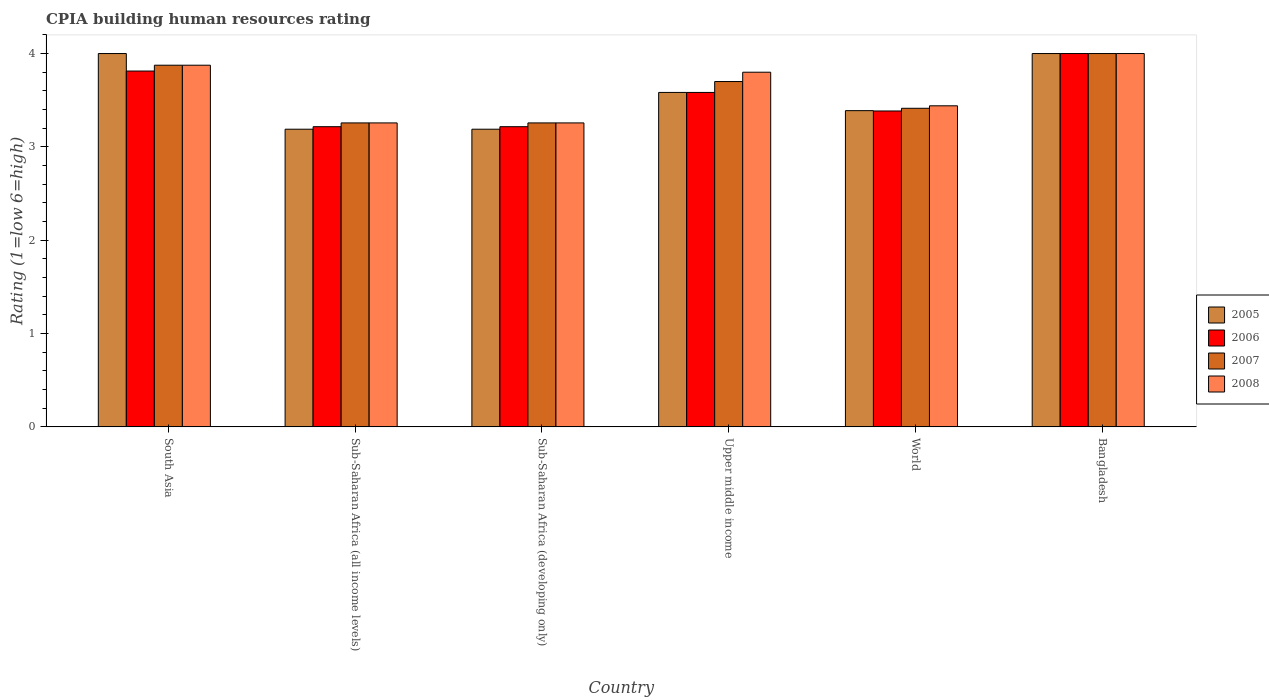How many different coloured bars are there?
Your response must be concise. 4. How many groups of bars are there?
Your answer should be compact. 6. Are the number of bars on each tick of the X-axis equal?
Make the answer very short. Yes. How many bars are there on the 1st tick from the right?
Give a very brief answer. 4. What is the label of the 3rd group of bars from the left?
Offer a very short reply. Sub-Saharan Africa (developing only). In how many cases, is the number of bars for a given country not equal to the number of legend labels?
Provide a succinct answer. 0. What is the CPIA rating in 2005 in Bangladesh?
Your response must be concise. 4. Across all countries, what is the minimum CPIA rating in 2007?
Give a very brief answer. 3.26. In which country was the CPIA rating in 2008 maximum?
Provide a short and direct response. Bangladesh. In which country was the CPIA rating in 2007 minimum?
Your response must be concise. Sub-Saharan Africa (all income levels). What is the total CPIA rating in 2005 in the graph?
Ensure brevity in your answer.  21.35. What is the difference between the CPIA rating in 2007 in Sub-Saharan Africa (developing only) and that in World?
Make the answer very short. -0.16. What is the difference between the CPIA rating in 2007 in Sub-Saharan Africa (all income levels) and the CPIA rating in 2005 in Sub-Saharan Africa (developing only)?
Your answer should be very brief. 0.07. What is the average CPIA rating in 2006 per country?
Ensure brevity in your answer.  3.54. What is the difference between the CPIA rating of/in 2008 and CPIA rating of/in 2005 in Upper middle income?
Offer a terse response. 0.22. What is the ratio of the CPIA rating in 2007 in Bangladesh to that in Sub-Saharan Africa (developing only)?
Offer a terse response. 1.23. What is the difference between the highest and the second highest CPIA rating in 2005?
Provide a short and direct response. -0.42. What is the difference between the highest and the lowest CPIA rating in 2007?
Your answer should be compact. 0.74. Is the sum of the CPIA rating in 2006 in South Asia and World greater than the maximum CPIA rating in 2007 across all countries?
Give a very brief answer. Yes. What does the 3rd bar from the left in Bangladesh represents?
Your response must be concise. 2007. What does the 1st bar from the right in Sub-Saharan Africa (all income levels) represents?
Your response must be concise. 2008. Is it the case that in every country, the sum of the CPIA rating in 2006 and CPIA rating in 2005 is greater than the CPIA rating in 2007?
Provide a short and direct response. Yes. What is the difference between two consecutive major ticks on the Y-axis?
Make the answer very short. 1. Does the graph contain any zero values?
Offer a terse response. No. Does the graph contain grids?
Provide a succinct answer. No. How many legend labels are there?
Your response must be concise. 4. How are the legend labels stacked?
Provide a succinct answer. Vertical. What is the title of the graph?
Your answer should be very brief. CPIA building human resources rating. Does "1999" appear as one of the legend labels in the graph?
Your answer should be very brief. No. What is the label or title of the X-axis?
Your response must be concise. Country. What is the label or title of the Y-axis?
Offer a very short reply. Rating (1=low 6=high). What is the Rating (1=low 6=high) in 2006 in South Asia?
Ensure brevity in your answer.  3.81. What is the Rating (1=low 6=high) of 2007 in South Asia?
Make the answer very short. 3.88. What is the Rating (1=low 6=high) of 2008 in South Asia?
Offer a very short reply. 3.88. What is the Rating (1=low 6=high) of 2005 in Sub-Saharan Africa (all income levels)?
Provide a succinct answer. 3.19. What is the Rating (1=low 6=high) of 2006 in Sub-Saharan Africa (all income levels)?
Provide a succinct answer. 3.22. What is the Rating (1=low 6=high) of 2007 in Sub-Saharan Africa (all income levels)?
Give a very brief answer. 3.26. What is the Rating (1=low 6=high) of 2008 in Sub-Saharan Africa (all income levels)?
Your answer should be very brief. 3.26. What is the Rating (1=low 6=high) in 2005 in Sub-Saharan Africa (developing only)?
Offer a very short reply. 3.19. What is the Rating (1=low 6=high) in 2006 in Sub-Saharan Africa (developing only)?
Make the answer very short. 3.22. What is the Rating (1=low 6=high) of 2007 in Sub-Saharan Africa (developing only)?
Provide a short and direct response. 3.26. What is the Rating (1=low 6=high) of 2008 in Sub-Saharan Africa (developing only)?
Make the answer very short. 3.26. What is the Rating (1=low 6=high) of 2005 in Upper middle income?
Your answer should be compact. 3.58. What is the Rating (1=low 6=high) in 2006 in Upper middle income?
Your answer should be very brief. 3.58. What is the Rating (1=low 6=high) of 2007 in Upper middle income?
Provide a short and direct response. 3.7. What is the Rating (1=low 6=high) of 2005 in World?
Make the answer very short. 3.39. What is the Rating (1=low 6=high) of 2006 in World?
Offer a very short reply. 3.38. What is the Rating (1=low 6=high) of 2007 in World?
Offer a terse response. 3.41. What is the Rating (1=low 6=high) of 2008 in World?
Your answer should be compact. 3.44. What is the Rating (1=low 6=high) in 2006 in Bangladesh?
Offer a very short reply. 4. What is the Rating (1=low 6=high) of 2007 in Bangladesh?
Keep it short and to the point. 4. What is the Rating (1=low 6=high) of 2008 in Bangladesh?
Your answer should be compact. 4. Across all countries, what is the maximum Rating (1=low 6=high) in 2006?
Offer a terse response. 4. Across all countries, what is the maximum Rating (1=low 6=high) of 2008?
Your answer should be very brief. 4. Across all countries, what is the minimum Rating (1=low 6=high) of 2005?
Give a very brief answer. 3.19. Across all countries, what is the minimum Rating (1=low 6=high) of 2006?
Provide a short and direct response. 3.22. Across all countries, what is the minimum Rating (1=low 6=high) in 2007?
Provide a short and direct response. 3.26. Across all countries, what is the minimum Rating (1=low 6=high) of 2008?
Keep it short and to the point. 3.26. What is the total Rating (1=low 6=high) in 2005 in the graph?
Provide a succinct answer. 21.35. What is the total Rating (1=low 6=high) of 2006 in the graph?
Your answer should be compact. 21.21. What is the total Rating (1=low 6=high) of 2007 in the graph?
Offer a terse response. 21.5. What is the total Rating (1=low 6=high) of 2008 in the graph?
Your answer should be very brief. 21.63. What is the difference between the Rating (1=low 6=high) of 2005 in South Asia and that in Sub-Saharan Africa (all income levels)?
Make the answer very short. 0.81. What is the difference between the Rating (1=low 6=high) of 2006 in South Asia and that in Sub-Saharan Africa (all income levels)?
Give a very brief answer. 0.6. What is the difference between the Rating (1=low 6=high) in 2007 in South Asia and that in Sub-Saharan Africa (all income levels)?
Provide a succinct answer. 0.62. What is the difference between the Rating (1=low 6=high) in 2008 in South Asia and that in Sub-Saharan Africa (all income levels)?
Make the answer very short. 0.62. What is the difference between the Rating (1=low 6=high) of 2005 in South Asia and that in Sub-Saharan Africa (developing only)?
Offer a very short reply. 0.81. What is the difference between the Rating (1=low 6=high) in 2006 in South Asia and that in Sub-Saharan Africa (developing only)?
Your answer should be compact. 0.6. What is the difference between the Rating (1=low 6=high) of 2007 in South Asia and that in Sub-Saharan Africa (developing only)?
Provide a succinct answer. 0.62. What is the difference between the Rating (1=low 6=high) in 2008 in South Asia and that in Sub-Saharan Africa (developing only)?
Your answer should be compact. 0.62. What is the difference between the Rating (1=low 6=high) in 2005 in South Asia and that in Upper middle income?
Offer a terse response. 0.42. What is the difference between the Rating (1=low 6=high) in 2006 in South Asia and that in Upper middle income?
Make the answer very short. 0.23. What is the difference between the Rating (1=low 6=high) in 2007 in South Asia and that in Upper middle income?
Make the answer very short. 0.17. What is the difference between the Rating (1=low 6=high) of 2008 in South Asia and that in Upper middle income?
Keep it short and to the point. 0.07. What is the difference between the Rating (1=low 6=high) in 2005 in South Asia and that in World?
Your answer should be compact. 0.61. What is the difference between the Rating (1=low 6=high) in 2006 in South Asia and that in World?
Ensure brevity in your answer.  0.43. What is the difference between the Rating (1=low 6=high) of 2007 in South Asia and that in World?
Offer a terse response. 0.46. What is the difference between the Rating (1=low 6=high) in 2008 in South Asia and that in World?
Your response must be concise. 0.43. What is the difference between the Rating (1=low 6=high) of 2006 in South Asia and that in Bangladesh?
Your answer should be compact. -0.19. What is the difference between the Rating (1=low 6=high) in 2007 in South Asia and that in Bangladesh?
Give a very brief answer. -0.12. What is the difference between the Rating (1=low 6=high) in 2008 in South Asia and that in Bangladesh?
Offer a very short reply. -0.12. What is the difference between the Rating (1=low 6=high) of 2005 in Sub-Saharan Africa (all income levels) and that in Upper middle income?
Your answer should be very brief. -0.39. What is the difference between the Rating (1=low 6=high) in 2006 in Sub-Saharan Africa (all income levels) and that in Upper middle income?
Your answer should be very brief. -0.37. What is the difference between the Rating (1=low 6=high) in 2007 in Sub-Saharan Africa (all income levels) and that in Upper middle income?
Your response must be concise. -0.44. What is the difference between the Rating (1=low 6=high) in 2008 in Sub-Saharan Africa (all income levels) and that in Upper middle income?
Give a very brief answer. -0.54. What is the difference between the Rating (1=low 6=high) of 2005 in Sub-Saharan Africa (all income levels) and that in World?
Offer a terse response. -0.2. What is the difference between the Rating (1=low 6=high) in 2006 in Sub-Saharan Africa (all income levels) and that in World?
Keep it short and to the point. -0.17. What is the difference between the Rating (1=low 6=high) in 2007 in Sub-Saharan Africa (all income levels) and that in World?
Make the answer very short. -0.16. What is the difference between the Rating (1=low 6=high) in 2008 in Sub-Saharan Africa (all income levels) and that in World?
Give a very brief answer. -0.18. What is the difference between the Rating (1=low 6=high) of 2005 in Sub-Saharan Africa (all income levels) and that in Bangladesh?
Offer a terse response. -0.81. What is the difference between the Rating (1=low 6=high) in 2006 in Sub-Saharan Africa (all income levels) and that in Bangladesh?
Your answer should be compact. -0.78. What is the difference between the Rating (1=low 6=high) of 2007 in Sub-Saharan Africa (all income levels) and that in Bangladesh?
Keep it short and to the point. -0.74. What is the difference between the Rating (1=low 6=high) in 2008 in Sub-Saharan Africa (all income levels) and that in Bangladesh?
Give a very brief answer. -0.74. What is the difference between the Rating (1=low 6=high) of 2005 in Sub-Saharan Africa (developing only) and that in Upper middle income?
Keep it short and to the point. -0.39. What is the difference between the Rating (1=low 6=high) in 2006 in Sub-Saharan Africa (developing only) and that in Upper middle income?
Give a very brief answer. -0.37. What is the difference between the Rating (1=low 6=high) of 2007 in Sub-Saharan Africa (developing only) and that in Upper middle income?
Your answer should be compact. -0.44. What is the difference between the Rating (1=low 6=high) in 2008 in Sub-Saharan Africa (developing only) and that in Upper middle income?
Give a very brief answer. -0.54. What is the difference between the Rating (1=low 6=high) in 2005 in Sub-Saharan Africa (developing only) and that in World?
Your response must be concise. -0.2. What is the difference between the Rating (1=low 6=high) in 2006 in Sub-Saharan Africa (developing only) and that in World?
Offer a very short reply. -0.17. What is the difference between the Rating (1=low 6=high) in 2007 in Sub-Saharan Africa (developing only) and that in World?
Provide a succinct answer. -0.16. What is the difference between the Rating (1=low 6=high) of 2008 in Sub-Saharan Africa (developing only) and that in World?
Make the answer very short. -0.18. What is the difference between the Rating (1=low 6=high) in 2005 in Sub-Saharan Africa (developing only) and that in Bangladesh?
Offer a very short reply. -0.81. What is the difference between the Rating (1=low 6=high) in 2006 in Sub-Saharan Africa (developing only) and that in Bangladesh?
Offer a very short reply. -0.78. What is the difference between the Rating (1=low 6=high) in 2007 in Sub-Saharan Africa (developing only) and that in Bangladesh?
Your response must be concise. -0.74. What is the difference between the Rating (1=low 6=high) in 2008 in Sub-Saharan Africa (developing only) and that in Bangladesh?
Your answer should be very brief. -0.74. What is the difference between the Rating (1=low 6=high) of 2005 in Upper middle income and that in World?
Your response must be concise. 0.2. What is the difference between the Rating (1=low 6=high) in 2006 in Upper middle income and that in World?
Your answer should be compact. 0.2. What is the difference between the Rating (1=low 6=high) in 2007 in Upper middle income and that in World?
Your response must be concise. 0.29. What is the difference between the Rating (1=low 6=high) in 2008 in Upper middle income and that in World?
Your answer should be compact. 0.36. What is the difference between the Rating (1=low 6=high) in 2005 in Upper middle income and that in Bangladesh?
Offer a very short reply. -0.42. What is the difference between the Rating (1=low 6=high) in 2006 in Upper middle income and that in Bangladesh?
Provide a succinct answer. -0.42. What is the difference between the Rating (1=low 6=high) of 2008 in Upper middle income and that in Bangladesh?
Provide a short and direct response. -0.2. What is the difference between the Rating (1=low 6=high) of 2005 in World and that in Bangladesh?
Your response must be concise. -0.61. What is the difference between the Rating (1=low 6=high) of 2006 in World and that in Bangladesh?
Your answer should be very brief. -0.62. What is the difference between the Rating (1=low 6=high) in 2007 in World and that in Bangladesh?
Make the answer very short. -0.59. What is the difference between the Rating (1=low 6=high) of 2008 in World and that in Bangladesh?
Give a very brief answer. -0.56. What is the difference between the Rating (1=low 6=high) in 2005 in South Asia and the Rating (1=low 6=high) in 2006 in Sub-Saharan Africa (all income levels)?
Keep it short and to the point. 0.78. What is the difference between the Rating (1=low 6=high) in 2005 in South Asia and the Rating (1=low 6=high) in 2007 in Sub-Saharan Africa (all income levels)?
Your answer should be compact. 0.74. What is the difference between the Rating (1=low 6=high) of 2005 in South Asia and the Rating (1=low 6=high) of 2008 in Sub-Saharan Africa (all income levels)?
Provide a short and direct response. 0.74. What is the difference between the Rating (1=low 6=high) in 2006 in South Asia and the Rating (1=low 6=high) in 2007 in Sub-Saharan Africa (all income levels)?
Offer a terse response. 0.56. What is the difference between the Rating (1=low 6=high) of 2006 in South Asia and the Rating (1=low 6=high) of 2008 in Sub-Saharan Africa (all income levels)?
Provide a succinct answer. 0.56. What is the difference between the Rating (1=low 6=high) in 2007 in South Asia and the Rating (1=low 6=high) in 2008 in Sub-Saharan Africa (all income levels)?
Keep it short and to the point. 0.62. What is the difference between the Rating (1=low 6=high) of 2005 in South Asia and the Rating (1=low 6=high) of 2006 in Sub-Saharan Africa (developing only)?
Provide a succinct answer. 0.78. What is the difference between the Rating (1=low 6=high) of 2005 in South Asia and the Rating (1=low 6=high) of 2007 in Sub-Saharan Africa (developing only)?
Your answer should be very brief. 0.74. What is the difference between the Rating (1=low 6=high) of 2005 in South Asia and the Rating (1=low 6=high) of 2008 in Sub-Saharan Africa (developing only)?
Give a very brief answer. 0.74. What is the difference between the Rating (1=low 6=high) of 2006 in South Asia and the Rating (1=low 6=high) of 2007 in Sub-Saharan Africa (developing only)?
Offer a terse response. 0.56. What is the difference between the Rating (1=low 6=high) in 2006 in South Asia and the Rating (1=low 6=high) in 2008 in Sub-Saharan Africa (developing only)?
Make the answer very short. 0.56. What is the difference between the Rating (1=low 6=high) in 2007 in South Asia and the Rating (1=low 6=high) in 2008 in Sub-Saharan Africa (developing only)?
Your answer should be very brief. 0.62. What is the difference between the Rating (1=low 6=high) in 2005 in South Asia and the Rating (1=low 6=high) in 2006 in Upper middle income?
Your answer should be very brief. 0.42. What is the difference between the Rating (1=low 6=high) in 2005 in South Asia and the Rating (1=low 6=high) in 2008 in Upper middle income?
Offer a very short reply. 0.2. What is the difference between the Rating (1=low 6=high) in 2006 in South Asia and the Rating (1=low 6=high) in 2007 in Upper middle income?
Provide a short and direct response. 0.11. What is the difference between the Rating (1=low 6=high) in 2006 in South Asia and the Rating (1=low 6=high) in 2008 in Upper middle income?
Ensure brevity in your answer.  0.01. What is the difference between the Rating (1=low 6=high) in 2007 in South Asia and the Rating (1=low 6=high) in 2008 in Upper middle income?
Keep it short and to the point. 0.07. What is the difference between the Rating (1=low 6=high) of 2005 in South Asia and the Rating (1=low 6=high) of 2006 in World?
Offer a terse response. 0.62. What is the difference between the Rating (1=low 6=high) of 2005 in South Asia and the Rating (1=low 6=high) of 2007 in World?
Make the answer very short. 0.59. What is the difference between the Rating (1=low 6=high) in 2005 in South Asia and the Rating (1=low 6=high) in 2008 in World?
Provide a succinct answer. 0.56. What is the difference between the Rating (1=low 6=high) in 2006 in South Asia and the Rating (1=low 6=high) in 2007 in World?
Your answer should be compact. 0.4. What is the difference between the Rating (1=low 6=high) of 2006 in South Asia and the Rating (1=low 6=high) of 2008 in World?
Make the answer very short. 0.37. What is the difference between the Rating (1=low 6=high) in 2007 in South Asia and the Rating (1=low 6=high) in 2008 in World?
Your answer should be very brief. 0.43. What is the difference between the Rating (1=low 6=high) in 2006 in South Asia and the Rating (1=low 6=high) in 2007 in Bangladesh?
Keep it short and to the point. -0.19. What is the difference between the Rating (1=low 6=high) of 2006 in South Asia and the Rating (1=low 6=high) of 2008 in Bangladesh?
Your answer should be compact. -0.19. What is the difference between the Rating (1=low 6=high) of 2007 in South Asia and the Rating (1=low 6=high) of 2008 in Bangladesh?
Your answer should be very brief. -0.12. What is the difference between the Rating (1=low 6=high) of 2005 in Sub-Saharan Africa (all income levels) and the Rating (1=low 6=high) of 2006 in Sub-Saharan Africa (developing only)?
Your answer should be very brief. -0.03. What is the difference between the Rating (1=low 6=high) in 2005 in Sub-Saharan Africa (all income levels) and the Rating (1=low 6=high) in 2007 in Sub-Saharan Africa (developing only)?
Keep it short and to the point. -0.07. What is the difference between the Rating (1=low 6=high) in 2005 in Sub-Saharan Africa (all income levels) and the Rating (1=low 6=high) in 2008 in Sub-Saharan Africa (developing only)?
Your response must be concise. -0.07. What is the difference between the Rating (1=low 6=high) in 2006 in Sub-Saharan Africa (all income levels) and the Rating (1=low 6=high) in 2007 in Sub-Saharan Africa (developing only)?
Offer a terse response. -0.04. What is the difference between the Rating (1=low 6=high) of 2006 in Sub-Saharan Africa (all income levels) and the Rating (1=low 6=high) of 2008 in Sub-Saharan Africa (developing only)?
Offer a terse response. -0.04. What is the difference between the Rating (1=low 6=high) of 2005 in Sub-Saharan Africa (all income levels) and the Rating (1=low 6=high) of 2006 in Upper middle income?
Ensure brevity in your answer.  -0.39. What is the difference between the Rating (1=low 6=high) in 2005 in Sub-Saharan Africa (all income levels) and the Rating (1=low 6=high) in 2007 in Upper middle income?
Keep it short and to the point. -0.51. What is the difference between the Rating (1=low 6=high) of 2005 in Sub-Saharan Africa (all income levels) and the Rating (1=low 6=high) of 2008 in Upper middle income?
Your answer should be compact. -0.61. What is the difference between the Rating (1=low 6=high) in 2006 in Sub-Saharan Africa (all income levels) and the Rating (1=low 6=high) in 2007 in Upper middle income?
Offer a very short reply. -0.48. What is the difference between the Rating (1=low 6=high) in 2006 in Sub-Saharan Africa (all income levels) and the Rating (1=low 6=high) in 2008 in Upper middle income?
Offer a terse response. -0.58. What is the difference between the Rating (1=low 6=high) in 2007 in Sub-Saharan Africa (all income levels) and the Rating (1=low 6=high) in 2008 in Upper middle income?
Provide a short and direct response. -0.54. What is the difference between the Rating (1=low 6=high) of 2005 in Sub-Saharan Africa (all income levels) and the Rating (1=low 6=high) of 2006 in World?
Your response must be concise. -0.2. What is the difference between the Rating (1=low 6=high) of 2005 in Sub-Saharan Africa (all income levels) and the Rating (1=low 6=high) of 2007 in World?
Offer a very short reply. -0.22. What is the difference between the Rating (1=low 6=high) of 2005 in Sub-Saharan Africa (all income levels) and the Rating (1=low 6=high) of 2008 in World?
Provide a short and direct response. -0.25. What is the difference between the Rating (1=low 6=high) in 2006 in Sub-Saharan Africa (all income levels) and the Rating (1=low 6=high) in 2007 in World?
Provide a succinct answer. -0.2. What is the difference between the Rating (1=low 6=high) in 2006 in Sub-Saharan Africa (all income levels) and the Rating (1=low 6=high) in 2008 in World?
Your response must be concise. -0.22. What is the difference between the Rating (1=low 6=high) of 2007 in Sub-Saharan Africa (all income levels) and the Rating (1=low 6=high) of 2008 in World?
Ensure brevity in your answer.  -0.18. What is the difference between the Rating (1=low 6=high) in 2005 in Sub-Saharan Africa (all income levels) and the Rating (1=low 6=high) in 2006 in Bangladesh?
Provide a short and direct response. -0.81. What is the difference between the Rating (1=low 6=high) of 2005 in Sub-Saharan Africa (all income levels) and the Rating (1=low 6=high) of 2007 in Bangladesh?
Keep it short and to the point. -0.81. What is the difference between the Rating (1=low 6=high) in 2005 in Sub-Saharan Africa (all income levels) and the Rating (1=low 6=high) in 2008 in Bangladesh?
Provide a short and direct response. -0.81. What is the difference between the Rating (1=low 6=high) of 2006 in Sub-Saharan Africa (all income levels) and the Rating (1=low 6=high) of 2007 in Bangladesh?
Your answer should be very brief. -0.78. What is the difference between the Rating (1=low 6=high) of 2006 in Sub-Saharan Africa (all income levels) and the Rating (1=low 6=high) of 2008 in Bangladesh?
Offer a very short reply. -0.78. What is the difference between the Rating (1=low 6=high) of 2007 in Sub-Saharan Africa (all income levels) and the Rating (1=low 6=high) of 2008 in Bangladesh?
Give a very brief answer. -0.74. What is the difference between the Rating (1=low 6=high) of 2005 in Sub-Saharan Africa (developing only) and the Rating (1=low 6=high) of 2006 in Upper middle income?
Make the answer very short. -0.39. What is the difference between the Rating (1=low 6=high) in 2005 in Sub-Saharan Africa (developing only) and the Rating (1=low 6=high) in 2007 in Upper middle income?
Offer a very short reply. -0.51. What is the difference between the Rating (1=low 6=high) of 2005 in Sub-Saharan Africa (developing only) and the Rating (1=low 6=high) of 2008 in Upper middle income?
Provide a succinct answer. -0.61. What is the difference between the Rating (1=low 6=high) of 2006 in Sub-Saharan Africa (developing only) and the Rating (1=low 6=high) of 2007 in Upper middle income?
Offer a very short reply. -0.48. What is the difference between the Rating (1=low 6=high) in 2006 in Sub-Saharan Africa (developing only) and the Rating (1=low 6=high) in 2008 in Upper middle income?
Keep it short and to the point. -0.58. What is the difference between the Rating (1=low 6=high) in 2007 in Sub-Saharan Africa (developing only) and the Rating (1=low 6=high) in 2008 in Upper middle income?
Provide a succinct answer. -0.54. What is the difference between the Rating (1=low 6=high) in 2005 in Sub-Saharan Africa (developing only) and the Rating (1=low 6=high) in 2006 in World?
Your answer should be very brief. -0.2. What is the difference between the Rating (1=low 6=high) in 2005 in Sub-Saharan Africa (developing only) and the Rating (1=low 6=high) in 2007 in World?
Offer a very short reply. -0.22. What is the difference between the Rating (1=low 6=high) in 2005 in Sub-Saharan Africa (developing only) and the Rating (1=low 6=high) in 2008 in World?
Give a very brief answer. -0.25. What is the difference between the Rating (1=low 6=high) in 2006 in Sub-Saharan Africa (developing only) and the Rating (1=low 6=high) in 2007 in World?
Offer a very short reply. -0.2. What is the difference between the Rating (1=low 6=high) of 2006 in Sub-Saharan Africa (developing only) and the Rating (1=low 6=high) of 2008 in World?
Your answer should be very brief. -0.22. What is the difference between the Rating (1=low 6=high) in 2007 in Sub-Saharan Africa (developing only) and the Rating (1=low 6=high) in 2008 in World?
Keep it short and to the point. -0.18. What is the difference between the Rating (1=low 6=high) in 2005 in Sub-Saharan Africa (developing only) and the Rating (1=low 6=high) in 2006 in Bangladesh?
Make the answer very short. -0.81. What is the difference between the Rating (1=low 6=high) in 2005 in Sub-Saharan Africa (developing only) and the Rating (1=low 6=high) in 2007 in Bangladesh?
Provide a short and direct response. -0.81. What is the difference between the Rating (1=low 6=high) of 2005 in Sub-Saharan Africa (developing only) and the Rating (1=low 6=high) of 2008 in Bangladesh?
Give a very brief answer. -0.81. What is the difference between the Rating (1=low 6=high) in 2006 in Sub-Saharan Africa (developing only) and the Rating (1=low 6=high) in 2007 in Bangladesh?
Offer a very short reply. -0.78. What is the difference between the Rating (1=low 6=high) of 2006 in Sub-Saharan Africa (developing only) and the Rating (1=low 6=high) of 2008 in Bangladesh?
Provide a short and direct response. -0.78. What is the difference between the Rating (1=low 6=high) in 2007 in Sub-Saharan Africa (developing only) and the Rating (1=low 6=high) in 2008 in Bangladesh?
Your answer should be very brief. -0.74. What is the difference between the Rating (1=low 6=high) of 2005 in Upper middle income and the Rating (1=low 6=high) of 2006 in World?
Your answer should be compact. 0.2. What is the difference between the Rating (1=low 6=high) of 2005 in Upper middle income and the Rating (1=low 6=high) of 2007 in World?
Offer a very short reply. 0.17. What is the difference between the Rating (1=low 6=high) in 2005 in Upper middle income and the Rating (1=low 6=high) in 2008 in World?
Your answer should be compact. 0.14. What is the difference between the Rating (1=low 6=high) in 2006 in Upper middle income and the Rating (1=low 6=high) in 2007 in World?
Your answer should be compact. 0.17. What is the difference between the Rating (1=low 6=high) of 2006 in Upper middle income and the Rating (1=low 6=high) of 2008 in World?
Make the answer very short. 0.14. What is the difference between the Rating (1=low 6=high) in 2007 in Upper middle income and the Rating (1=low 6=high) in 2008 in World?
Your answer should be very brief. 0.26. What is the difference between the Rating (1=low 6=high) of 2005 in Upper middle income and the Rating (1=low 6=high) of 2006 in Bangladesh?
Provide a short and direct response. -0.42. What is the difference between the Rating (1=low 6=high) of 2005 in Upper middle income and the Rating (1=low 6=high) of 2007 in Bangladesh?
Keep it short and to the point. -0.42. What is the difference between the Rating (1=low 6=high) in 2005 in Upper middle income and the Rating (1=low 6=high) in 2008 in Bangladesh?
Make the answer very short. -0.42. What is the difference between the Rating (1=low 6=high) in 2006 in Upper middle income and the Rating (1=low 6=high) in 2007 in Bangladesh?
Your answer should be compact. -0.42. What is the difference between the Rating (1=low 6=high) in 2006 in Upper middle income and the Rating (1=low 6=high) in 2008 in Bangladesh?
Offer a very short reply. -0.42. What is the difference between the Rating (1=low 6=high) in 2005 in World and the Rating (1=low 6=high) in 2006 in Bangladesh?
Keep it short and to the point. -0.61. What is the difference between the Rating (1=low 6=high) in 2005 in World and the Rating (1=low 6=high) in 2007 in Bangladesh?
Make the answer very short. -0.61. What is the difference between the Rating (1=low 6=high) in 2005 in World and the Rating (1=low 6=high) in 2008 in Bangladesh?
Make the answer very short. -0.61. What is the difference between the Rating (1=low 6=high) in 2006 in World and the Rating (1=low 6=high) in 2007 in Bangladesh?
Ensure brevity in your answer.  -0.62. What is the difference between the Rating (1=low 6=high) of 2006 in World and the Rating (1=low 6=high) of 2008 in Bangladesh?
Offer a very short reply. -0.62. What is the difference between the Rating (1=low 6=high) in 2007 in World and the Rating (1=low 6=high) in 2008 in Bangladesh?
Provide a short and direct response. -0.59. What is the average Rating (1=low 6=high) of 2005 per country?
Give a very brief answer. 3.56. What is the average Rating (1=low 6=high) in 2006 per country?
Keep it short and to the point. 3.54. What is the average Rating (1=low 6=high) in 2007 per country?
Make the answer very short. 3.58. What is the average Rating (1=low 6=high) in 2008 per country?
Your response must be concise. 3.6. What is the difference between the Rating (1=low 6=high) in 2005 and Rating (1=low 6=high) in 2006 in South Asia?
Keep it short and to the point. 0.19. What is the difference between the Rating (1=low 6=high) in 2005 and Rating (1=low 6=high) in 2007 in South Asia?
Give a very brief answer. 0.12. What is the difference between the Rating (1=low 6=high) of 2005 and Rating (1=low 6=high) of 2008 in South Asia?
Provide a succinct answer. 0.12. What is the difference between the Rating (1=low 6=high) of 2006 and Rating (1=low 6=high) of 2007 in South Asia?
Your answer should be compact. -0.06. What is the difference between the Rating (1=low 6=high) of 2006 and Rating (1=low 6=high) of 2008 in South Asia?
Your response must be concise. -0.06. What is the difference between the Rating (1=low 6=high) in 2005 and Rating (1=low 6=high) in 2006 in Sub-Saharan Africa (all income levels)?
Make the answer very short. -0.03. What is the difference between the Rating (1=low 6=high) in 2005 and Rating (1=low 6=high) in 2007 in Sub-Saharan Africa (all income levels)?
Provide a succinct answer. -0.07. What is the difference between the Rating (1=low 6=high) in 2005 and Rating (1=low 6=high) in 2008 in Sub-Saharan Africa (all income levels)?
Make the answer very short. -0.07. What is the difference between the Rating (1=low 6=high) in 2006 and Rating (1=low 6=high) in 2007 in Sub-Saharan Africa (all income levels)?
Provide a short and direct response. -0.04. What is the difference between the Rating (1=low 6=high) in 2006 and Rating (1=low 6=high) in 2008 in Sub-Saharan Africa (all income levels)?
Offer a terse response. -0.04. What is the difference between the Rating (1=low 6=high) in 2007 and Rating (1=low 6=high) in 2008 in Sub-Saharan Africa (all income levels)?
Your answer should be compact. 0. What is the difference between the Rating (1=low 6=high) of 2005 and Rating (1=low 6=high) of 2006 in Sub-Saharan Africa (developing only)?
Provide a succinct answer. -0.03. What is the difference between the Rating (1=low 6=high) in 2005 and Rating (1=low 6=high) in 2007 in Sub-Saharan Africa (developing only)?
Provide a short and direct response. -0.07. What is the difference between the Rating (1=low 6=high) of 2005 and Rating (1=low 6=high) of 2008 in Sub-Saharan Africa (developing only)?
Offer a terse response. -0.07. What is the difference between the Rating (1=low 6=high) in 2006 and Rating (1=low 6=high) in 2007 in Sub-Saharan Africa (developing only)?
Offer a terse response. -0.04. What is the difference between the Rating (1=low 6=high) of 2006 and Rating (1=low 6=high) of 2008 in Sub-Saharan Africa (developing only)?
Provide a succinct answer. -0.04. What is the difference between the Rating (1=low 6=high) in 2005 and Rating (1=low 6=high) in 2007 in Upper middle income?
Your answer should be compact. -0.12. What is the difference between the Rating (1=low 6=high) in 2005 and Rating (1=low 6=high) in 2008 in Upper middle income?
Your response must be concise. -0.22. What is the difference between the Rating (1=low 6=high) of 2006 and Rating (1=low 6=high) of 2007 in Upper middle income?
Provide a short and direct response. -0.12. What is the difference between the Rating (1=low 6=high) of 2006 and Rating (1=low 6=high) of 2008 in Upper middle income?
Your response must be concise. -0.22. What is the difference between the Rating (1=low 6=high) of 2005 and Rating (1=low 6=high) of 2006 in World?
Your response must be concise. 0. What is the difference between the Rating (1=low 6=high) in 2005 and Rating (1=low 6=high) in 2007 in World?
Your response must be concise. -0.03. What is the difference between the Rating (1=low 6=high) of 2005 and Rating (1=low 6=high) of 2008 in World?
Your answer should be compact. -0.05. What is the difference between the Rating (1=low 6=high) of 2006 and Rating (1=low 6=high) of 2007 in World?
Keep it short and to the point. -0.03. What is the difference between the Rating (1=low 6=high) in 2006 and Rating (1=low 6=high) in 2008 in World?
Give a very brief answer. -0.06. What is the difference between the Rating (1=low 6=high) in 2007 and Rating (1=low 6=high) in 2008 in World?
Your response must be concise. -0.03. What is the difference between the Rating (1=low 6=high) of 2005 and Rating (1=low 6=high) of 2006 in Bangladesh?
Give a very brief answer. 0. What is the difference between the Rating (1=low 6=high) of 2005 and Rating (1=low 6=high) of 2008 in Bangladesh?
Your answer should be very brief. 0. What is the difference between the Rating (1=low 6=high) in 2006 and Rating (1=low 6=high) in 2007 in Bangladesh?
Provide a succinct answer. 0. What is the difference between the Rating (1=low 6=high) in 2007 and Rating (1=low 6=high) in 2008 in Bangladesh?
Your answer should be very brief. 0. What is the ratio of the Rating (1=low 6=high) in 2005 in South Asia to that in Sub-Saharan Africa (all income levels)?
Make the answer very short. 1.25. What is the ratio of the Rating (1=low 6=high) in 2006 in South Asia to that in Sub-Saharan Africa (all income levels)?
Provide a succinct answer. 1.19. What is the ratio of the Rating (1=low 6=high) in 2007 in South Asia to that in Sub-Saharan Africa (all income levels)?
Your response must be concise. 1.19. What is the ratio of the Rating (1=low 6=high) in 2008 in South Asia to that in Sub-Saharan Africa (all income levels)?
Offer a terse response. 1.19. What is the ratio of the Rating (1=low 6=high) in 2005 in South Asia to that in Sub-Saharan Africa (developing only)?
Ensure brevity in your answer.  1.25. What is the ratio of the Rating (1=low 6=high) of 2006 in South Asia to that in Sub-Saharan Africa (developing only)?
Your answer should be very brief. 1.19. What is the ratio of the Rating (1=low 6=high) of 2007 in South Asia to that in Sub-Saharan Africa (developing only)?
Your response must be concise. 1.19. What is the ratio of the Rating (1=low 6=high) in 2008 in South Asia to that in Sub-Saharan Africa (developing only)?
Your answer should be compact. 1.19. What is the ratio of the Rating (1=low 6=high) of 2005 in South Asia to that in Upper middle income?
Offer a very short reply. 1.12. What is the ratio of the Rating (1=low 6=high) of 2006 in South Asia to that in Upper middle income?
Make the answer very short. 1.06. What is the ratio of the Rating (1=low 6=high) in 2007 in South Asia to that in Upper middle income?
Your answer should be very brief. 1.05. What is the ratio of the Rating (1=low 6=high) in 2008 in South Asia to that in Upper middle income?
Give a very brief answer. 1.02. What is the ratio of the Rating (1=low 6=high) of 2005 in South Asia to that in World?
Your response must be concise. 1.18. What is the ratio of the Rating (1=low 6=high) in 2006 in South Asia to that in World?
Ensure brevity in your answer.  1.13. What is the ratio of the Rating (1=low 6=high) in 2007 in South Asia to that in World?
Your answer should be compact. 1.14. What is the ratio of the Rating (1=low 6=high) of 2008 in South Asia to that in World?
Your response must be concise. 1.13. What is the ratio of the Rating (1=low 6=high) of 2005 in South Asia to that in Bangladesh?
Give a very brief answer. 1. What is the ratio of the Rating (1=low 6=high) in 2006 in South Asia to that in Bangladesh?
Your answer should be compact. 0.95. What is the ratio of the Rating (1=low 6=high) in 2007 in South Asia to that in Bangladesh?
Make the answer very short. 0.97. What is the ratio of the Rating (1=low 6=high) in 2008 in South Asia to that in Bangladesh?
Keep it short and to the point. 0.97. What is the ratio of the Rating (1=low 6=high) in 2006 in Sub-Saharan Africa (all income levels) to that in Sub-Saharan Africa (developing only)?
Your answer should be compact. 1. What is the ratio of the Rating (1=low 6=high) of 2007 in Sub-Saharan Africa (all income levels) to that in Sub-Saharan Africa (developing only)?
Keep it short and to the point. 1. What is the ratio of the Rating (1=low 6=high) of 2005 in Sub-Saharan Africa (all income levels) to that in Upper middle income?
Provide a short and direct response. 0.89. What is the ratio of the Rating (1=low 6=high) of 2006 in Sub-Saharan Africa (all income levels) to that in Upper middle income?
Give a very brief answer. 0.9. What is the ratio of the Rating (1=low 6=high) of 2007 in Sub-Saharan Africa (all income levels) to that in Upper middle income?
Offer a very short reply. 0.88. What is the ratio of the Rating (1=low 6=high) in 2008 in Sub-Saharan Africa (all income levels) to that in Upper middle income?
Offer a very short reply. 0.86. What is the ratio of the Rating (1=low 6=high) of 2005 in Sub-Saharan Africa (all income levels) to that in World?
Ensure brevity in your answer.  0.94. What is the ratio of the Rating (1=low 6=high) in 2006 in Sub-Saharan Africa (all income levels) to that in World?
Your answer should be compact. 0.95. What is the ratio of the Rating (1=low 6=high) of 2007 in Sub-Saharan Africa (all income levels) to that in World?
Provide a short and direct response. 0.95. What is the ratio of the Rating (1=low 6=high) of 2008 in Sub-Saharan Africa (all income levels) to that in World?
Give a very brief answer. 0.95. What is the ratio of the Rating (1=low 6=high) in 2005 in Sub-Saharan Africa (all income levels) to that in Bangladesh?
Keep it short and to the point. 0.8. What is the ratio of the Rating (1=low 6=high) in 2006 in Sub-Saharan Africa (all income levels) to that in Bangladesh?
Ensure brevity in your answer.  0.8. What is the ratio of the Rating (1=low 6=high) of 2007 in Sub-Saharan Africa (all income levels) to that in Bangladesh?
Provide a short and direct response. 0.81. What is the ratio of the Rating (1=low 6=high) of 2008 in Sub-Saharan Africa (all income levels) to that in Bangladesh?
Your answer should be very brief. 0.81. What is the ratio of the Rating (1=low 6=high) of 2005 in Sub-Saharan Africa (developing only) to that in Upper middle income?
Your response must be concise. 0.89. What is the ratio of the Rating (1=low 6=high) of 2006 in Sub-Saharan Africa (developing only) to that in Upper middle income?
Provide a succinct answer. 0.9. What is the ratio of the Rating (1=low 6=high) in 2007 in Sub-Saharan Africa (developing only) to that in Upper middle income?
Offer a terse response. 0.88. What is the ratio of the Rating (1=low 6=high) in 2008 in Sub-Saharan Africa (developing only) to that in Upper middle income?
Provide a short and direct response. 0.86. What is the ratio of the Rating (1=low 6=high) of 2005 in Sub-Saharan Africa (developing only) to that in World?
Make the answer very short. 0.94. What is the ratio of the Rating (1=low 6=high) of 2006 in Sub-Saharan Africa (developing only) to that in World?
Make the answer very short. 0.95. What is the ratio of the Rating (1=low 6=high) in 2007 in Sub-Saharan Africa (developing only) to that in World?
Provide a succinct answer. 0.95. What is the ratio of the Rating (1=low 6=high) in 2008 in Sub-Saharan Africa (developing only) to that in World?
Give a very brief answer. 0.95. What is the ratio of the Rating (1=low 6=high) of 2005 in Sub-Saharan Africa (developing only) to that in Bangladesh?
Keep it short and to the point. 0.8. What is the ratio of the Rating (1=low 6=high) in 2006 in Sub-Saharan Africa (developing only) to that in Bangladesh?
Offer a very short reply. 0.8. What is the ratio of the Rating (1=low 6=high) in 2007 in Sub-Saharan Africa (developing only) to that in Bangladesh?
Keep it short and to the point. 0.81. What is the ratio of the Rating (1=low 6=high) of 2008 in Sub-Saharan Africa (developing only) to that in Bangladesh?
Offer a very short reply. 0.81. What is the ratio of the Rating (1=low 6=high) of 2005 in Upper middle income to that in World?
Give a very brief answer. 1.06. What is the ratio of the Rating (1=low 6=high) of 2006 in Upper middle income to that in World?
Your answer should be compact. 1.06. What is the ratio of the Rating (1=low 6=high) in 2007 in Upper middle income to that in World?
Offer a terse response. 1.08. What is the ratio of the Rating (1=low 6=high) of 2008 in Upper middle income to that in World?
Give a very brief answer. 1.1. What is the ratio of the Rating (1=low 6=high) of 2005 in Upper middle income to that in Bangladesh?
Offer a very short reply. 0.9. What is the ratio of the Rating (1=low 6=high) of 2006 in Upper middle income to that in Bangladesh?
Your answer should be very brief. 0.9. What is the ratio of the Rating (1=low 6=high) in 2007 in Upper middle income to that in Bangladesh?
Your answer should be compact. 0.93. What is the ratio of the Rating (1=low 6=high) in 2005 in World to that in Bangladesh?
Ensure brevity in your answer.  0.85. What is the ratio of the Rating (1=low 6=high) in 2006 in World to that in Bangladesh?
Offer a terse response. 0.85. What is the ratio of the Rating (1=low 6=high) of 2007 in World to that in Bangladesh?
Offer a very short reply. 0.85. What is the ratio of the Rating (1=low 6=high) in 2008 in World to that in Bangladesh?
Give a very brief answer. 0.86. What is the difference between the highest and the second highest Rating (1=low 6=high) of 2005?
Ensure brevity in your answer.  0. What is the difference between the highest and the second highest Rating (1=low 6=high) of 2006?
Keep it short and to the point. 0.19. What is the difference between the highest and the lowest Rating (1=low 6=high) of 2005?
Offer a terse response. 0.81. What is the difference between the highest and the lowest Rating (1=low 6=high) in 2006?
Give a very brief answer. 0.78. What is the difference between the highest and the lowest Rating (1=low 6=high) of 2007?
Your response must be concise. 0.74. What is the difference between the highest and the lowest Rating (1=low 6=high) in 2008?
Offer a very short reply. 0.74. 